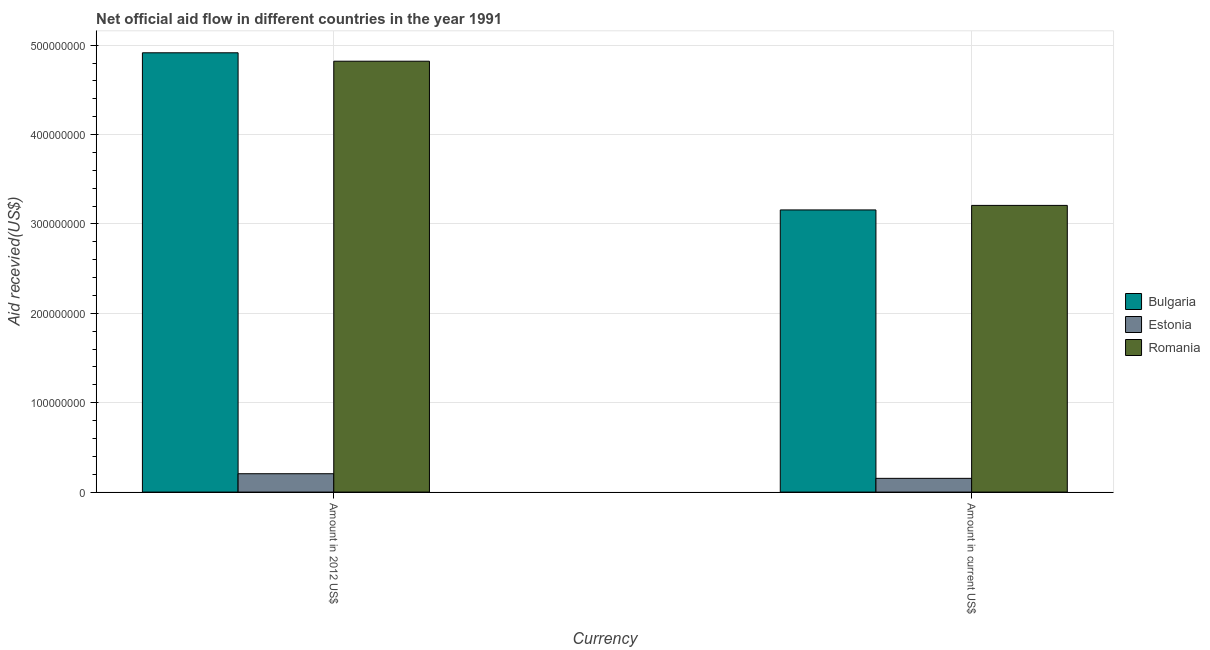Are the number of bars per tick equal to the number of legend labels?
Offer a terse response. Yes. How many bars are there on the 1st tick from the left?
Keep it short and to the point. 3. How many bars are there on the 2nd tick from the right?
Give a very brief answer. 3. What is the label of the 2nd group of bars from the left?
Provide a succinct answer. Amount in current US$. What is the amount of aid received(expressed in us$) in Bulgaria?
Offer a terse response. 3.16e+08. Across all countries, what is the maximum amount of aid received(expressed in 2012 us$)?
Your answer should be compact. 4.91e+08. Across all countries, what is the minimum amount of aid received(expressed in 2012 us$)?
Give a very brief answer. 2.05e+07. In which country was the amount of aid received(expressed in us$) maximum?
Provide a succinct answer. Romania. In which country was the amount of aid received(expressed in us$) minimum?
Offer a terse response. Estonia. What is the total amount of aid received(expressed in us$) in the graph?
Offer a very short reply. 6.52e+08. What is the difference between the amount of aid received(expressed in us$) in Estonia and that in Romania?
Offer a terse response. -3.05e+08. What is the difference between the amount of aid received(expressed in 2012 us$) in Estonia and the amount of aid received(expressed in us$) in Bulgaria?
Make the answer very short. -2.95e+08. What is the average amount of aid received(expressed in 2012 us$) per country?
Your response must be concise. 3.31e+08. What is the difference between the amount of aid received(expressed in 2012 us$) and amount of aid received(expressed in us$) in Romania?
Provide a succinct answer. 1.61e+08. In how many countries, is the amount of aid received(expressed in 2012 us$) greater than 60000000 US$?
Your answer should be very brief. 2. What is the ratio of the amount of aid received(expressed in us$) in Romania to that in Bulgaria?
Your response must be concise. 1.02. Is the amount of aid received(expressed in 2012 us$) in Bulgaria less than that in Estonia?
Offer a very short reply. No. What does the 2nd bar from the right in Amount in 2012 US$ represents?
Your answer should be very brief. Estonia. How many bars are there?
Keep it short and to the point. 6. Are all the bars in the graph horizontal?
Your answer should be very brief. No. What is the difference between two consecutive major ticks on the Y-axis?
Your response must be concise. 1.00e+08. Are the values on the major ticks of Y-axis written in scientific E-notation?
Offer a very short reply. No. Does the graph contain any zero values?
Make the answer very short. No. How many legend labels are there?
Offer a very short reply. 3. What is the title of the graph?
Your answer should be very brief. Net official aid flow in different countries in the year 1991. Does "Nicaragua" appear as one of the legend labels in the graph?
Give a very brief answer. No. What is the label or title of the X-axis?
Ensure brevity in your answer.  Currency. What is the label or title of the Y-axis?
Offer a very short reply. Aid recevied(US$). What is the Aid recevied(US$) of Bulgaria in Amount in 2012 US$?
Your answer should be compact. 4.91e+08. What is the Aid recevied(US$) in Estonia in Amount in 2012 US$?
Your answer should be compact. 2.05e+07. What is the Aid recevied(US$) of Romania in Amount in 2012 US$?
Make the answer very short. 4.82e+08. What is the Aid recevied(US$) in Bulgaria in Amount in current US$?
Your answer should be very brief. 3.16e+08. What is the Aid recevied(US$) in Estonia in Amount in current US$?
Give a very brief answer. 1.54e+07. What is the Aid recevied(US$) in Romania in Amount in current US$?
Offer a terse response. 3.21e+08. Across all Currency, what is the maximum Aid recevied(US$) of Bulgaria?
Your response must be concise. 4.91e+08. Across all Currency, what is the maximum Aid recevied(US$) of Estonia?
Make the answer very short. 2.05e+07. Across all Currency, what is the maximum Aid recevied(US$) in Romania?
Offer a very short reply. 4.82e+08. Across all Currency, what is the minimum Aid recevied(US$) in Bulgaria?
Make the answer very short. 3.16e+08. Across all Currency, what is the minimum Aid recevied(US$) of Estonia?
Your response must be concise. 1.54e+07. Across all Currency, what is the minimum Aid recevied(US$) in Romania?
Your answer should be very brief. 3.21e+08. What is the total Aid recevied(US$) of Bulgaria in the graph?
Your response must be concise. 8.07e+08. What is the total Aid recevied(US$) in Estonia in the graph?
Provide a succinct answer. 3.59e+07. What is the total Aid recevied(US$) of Romania in the graph?
Your response must be concise. 8.03e+08. What is the difference between the Aid recevied(US$) of Bulgaria in Amount in 2012 US$ and that in Amount in current US$?
Offer a very short reply. 1.76e+08. What is the difference between the Aid recevied(US$) of Estonia in Amount in 2012 US$ and that in Amount in current US$?
Offer a very short reply. 5.17e+06. What is the difference between the Aid recevied(US$) in Romania in Amount in 2012 US$ and that in Amount in current US$?
Your answer should be very brief. 1.61e+08. What is the difference between the Aid recevied(US$) of Bulgaria in Amount in 2012 US$ and the Aid recevied(US$) of Estonia in Amount in current US$?
Ensure brevity in your answer.  4.76e+08. What is the difference between the Aid recevied(US$) of Bulgaria in Amount in 2012 US$ and the Aid recevied(US$) of Romania in Amount in current US$?
Give a very brief answer. 1.71e+08. What is the difference between the Aid recevied(US$) of Estonia in Amount in 2012 US$ and the Aid recevied(US$) of Romania in Amount in current US$?
Offer a very short reply. -3.00e+08. What is the average Aid recevied(US$) in Bulgaria per Currency?
Offer a very short reply. 4.04e+08. What is the average Aid recevied(US$) of Estonia per Currency?
Ensure brevity in your answer.  1.80e+07. What is the average Aid recevied(US$) in Romania per Currency?
Your response must be concise. 4.01e+08. What is the difference between the Aid recevied(US$) of Bulgaria and Aid recevied(US$) of Estonia in Amount in 2012 US$?
Provide a succinct answer. 4.71e+08. What is the difference between the Aid recevied(US$) of Bulgaria and Aid recevied(US$) of Romania in Amount in 2012 US$?
Make the answer very short. 9.42e+06. What is the difference between the Aid recevied(US$) of Estonia and Aid recevied(US$) of Romania in Amount in 2012 US$?
Ensure brevity in your answer.  -4.62e+08. What is the difference between the Aid recevied(US$) of Bulgaria and Aid recevied(US$) of Estonia in Amount in current US$?
Provide a succinct answer. 3.00e+08. What is the difference between the Aid recevied(US$) in Bulgaria and Aid recevied(US$) in Romania in Amount in current US$?
Provide a succinct answer. -5.07e+06. What is the difference between the Aid recevied(US$) in Estonia and Aid recevied(US$) in Romania in Amount in current US$?
Ensure brevity in your answer.  -3.05e+08. What is the ratio of the Aid recevied(US$) in Bulgaria in Amount in 2012 US$ to that in Amount in current US$?
Offer a terse response. 1.56. What is the ratio of the Aid recevied(US$) in Estonia in Amount in 2012 US$ to that in Amount in current US$?
Keep it short and to the point. 1.34. What is the ratio of the Aid recevied(US$) of Romania in Amount in 2012 US$ to that in Amount in current US$?
Your response must be concise. 1.5. What is the difference between the highest and the second highest Aid recevied(US$) of Bulgaria?
Your answer should be compact. 1.76e+08. What is the difference between the highest and the second highest Aid recevied(US$) of Estonia?
Keep it short and to the point. 5.17e+06. What is the difference between the highest and the second highest Aid recevied(US$) in Romania?
Offer a terse response. 1.61e+08. What is the difference between the highest and the lowest Aid recevied(US$) of Bulgaria?
Your answer should be very brief. 1.76e+08. What is the difference between the highest and the lowest Aid recevied(US$) in Estonia?
Provide a short and direct response. 5.17e+06. What is the difference between the highest and the lowest Aid recevied(US$) in Romania?
Your response must be concise. 1.61e+08. 